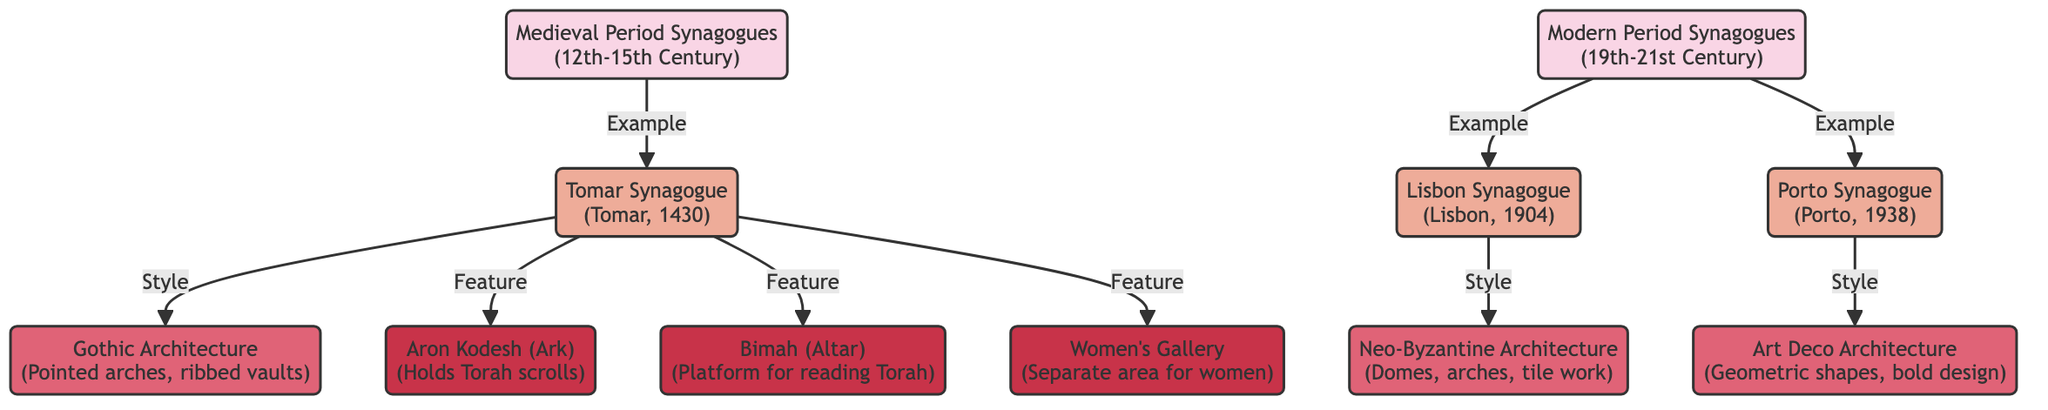What are the two periods represented in the diagram? The diagram represents the "Medieval Period Synagogues (12th-15th Century)" and the "Modern Period Synagogues (19th-21st Century)." These are the two primary nodes at the top level of the diagram.
Answer: Medieval Period Synagogues, Modern Period Synagogues How many synagogues are mentioned in the Medieval Period? The diagram features one specific synagogue from the Medieval Period, which is the "Tomar Synagogue (Tomar, 1430)." This is the only instance listed under the Medieval Period node.
Answer: 1 What architectural style is associated with the Porto Synagogue? The Porto Synagogue is associated with "Art Deco Architecture," as indicated by the specific link from the Porto Synagogue node to the Art Deco Architecture node in the diagram.
Answer: Art Deco Architecture Which feature is not present in the Tomar Synagogue? The Tomar Synagogue has three noted features: "Aron Kodesh," "Bimah," and "Women's Gallery." Since all are present, one could infer that any other feature not mentioned would be absent, such as "Men's Gallery." However, this is not explicitly stated and must be reasoned through absence.
Answer: Men's Gallery How is the Aron Kodesh related to the Tomar Synagogue? The "Aron Kodesh (Ark)" is one of the features directly linked to the "Tomar Synagogue" node, indicating it is a key architectural feature of that synagogue.
Answer: Holds Torah scrolls Which architectural style transitions from Medieval to Modern for the Tomar Synagogue? The architecture style of the Tomar Synagogue corresponds to "Gothic Architecture," while the architectural styles transitioning to the Modern Period include "Neo-Byzantine Architecture" and "Art Deco Architecture" for the other synagogues, indicating a progression in style.
Answer: Gothic Architecture What feature is only associated with the Medieval Period in the diagram? The features "Aron Kodesh," "Bimah," and "Women's Gallery" are all associated with the Tomar Synagogue, which belongs to the Medieval Period. Therefore, these features are exclusive to this period in the context of the synagogues presented.
Answer: Aron Kodesh, Bimah, Women's Gallery Which synagogue has the most recent construction date? The "Porto Synagogue (Porto, 1938)" is the most recent of the synagogues mentioned, compared to the Tomar Synagogue from 1430 and the Lisbon Synagogue from 1904. This places it chronologically last among the examples.
Answer: Porto Synagogue What architectural feature is common to both Medieval and Modern synagogues? The feature "Women's Gallery" is associated exclusively with the Medieval Period through the Tomar Synagogue, implying it may or may not be present in Modern designs, as no Modern synagogues have this feature noted in the diagram. Thus, we cannot infer a commonality in features without explicit mention for Modern synagogues.
Answer: None 